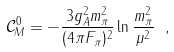Convert formula to latex. <formula><loc_0><loc_0><loc_500><loc_500>\mathcal { C } _ { M } ^ { 0 } = - \frac { 3 g _ { A } ^ { 2 } m _ { \pi } ^ { 2 } } { ( 4 \pi F _ { \pi } ) ^ { 2 } } \ln \frac { m _ { \pi } ^ { 2 } } { \mu ^ { 2 } } \ ,</formula> 